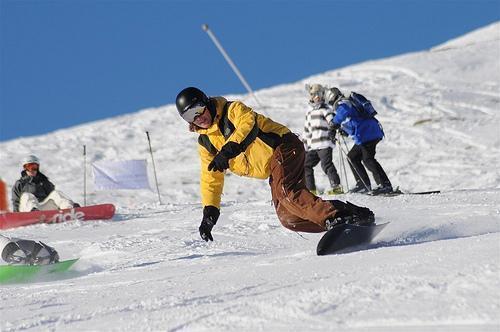How many people are in the picture?
Give a very brief answer. 4. How many trains are in front of the building?
Give a very brief answer. 0. 